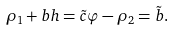Convert formula to latex. <formula><loc_0><loc_0><loc_500><loc_500>\rho _ { 1 } + b h = \tilde { c } \varphi - \rho _ { 2 } = \tilde { b } .</formula> 